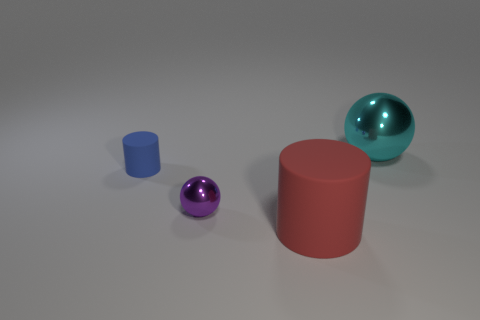The matte object that is to the left of the red cylinder has what shape?
Ensure brevity in your answer.  Cylinder. How many purple balls have the same size as the blue thing?
Your answer should be very brief. 1. There is a big thing behind the big cylinder; does it have the same color as the tiny cylinder?
Provide a short and direct response. No. There is a object that is both behind the big red cylinder and in front of the blue cylinder; what is its material?
Provide a short and direct response. Metal. Is the number of small spheres greater than the number of yellow blocks?
Your response must be concise. Yes. What color is the shiny sphere to the right of the large matte object in front of the shiny object in front of the tiny cylinder?
Provide a short and direct response. Cyan. Does the red thing in front of the cyan sphere have the same material as the small blue thing?
Offer a terse response. Yes. Are any small blue cubes visible?
Give a very brief answer. No. Do the rubber cylinder to the left of the red rubber cylinder and the small metal thing have the same size?
Your answer should be very brief. Yes. Are there fewer small purple metallic things than blue shiny cubes?
Make the answer very short. No. 